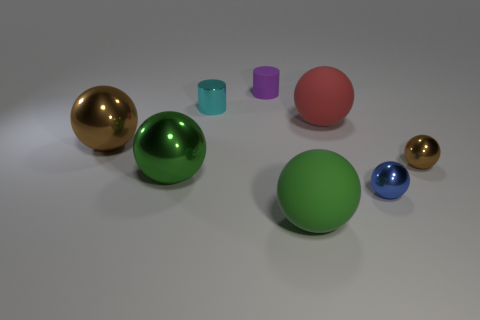There is a tiny object that is both right of the cyan object and behind the red sphere; what is its shape?
Keep it short and to the point. Cylinder. What size is the metallic sphere behind the brown metallic object that is right of the large red matte ball?
Provide a succinct answer. Large. What is the material of the other cyan thing that is the same shape as the tiny rubber object?
Offer a very short reply. Metal. What number of brown shiny balls are there?
Make the answer very short. 2. The large rubber thing in front of the big rubber ball that is right of the large matte thing that is in front of the tiny brown object is what color?
Provide a short and direct response. Green. Is the number of big balls less than the number of green objects?
Provide a short and direct response. No. What color is the other big shiny object that is the same shape as the large green shiny thing?
Give a very brief answer. Brown. The cylinder that is the same material as the big brown ball is what color?
Provide a succinct answer. Cyan. What number of brown objects have the same size as the cyan object?
Offer a very short reply. 1. What is the material of the small blue ball?
Give a very brief answer. Metal. 